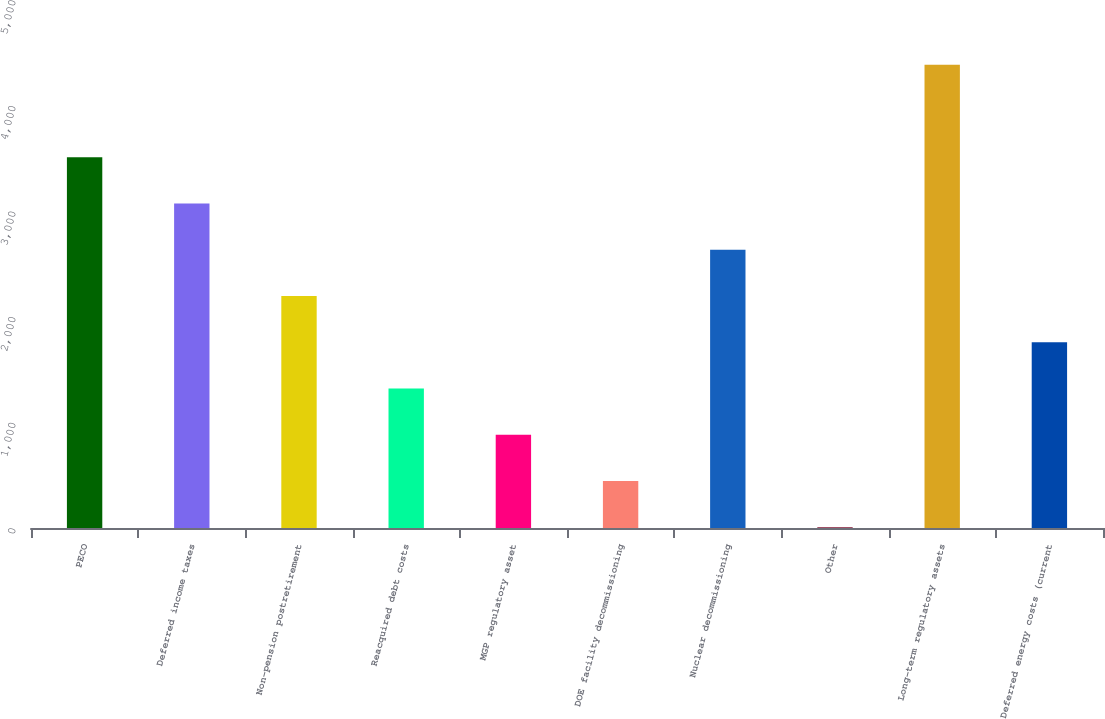Convert chart to OTSL. <chart><loc_0><loc_0><loc_500><loc_500><bar_chart><fcel>PECO<fcel>Deferred income taxes<fcel>Non-pension postretirement<fcel>Reacquired debt costs<fcel>MGP regulatory asset<fcel>DOE facility decommissioning<fcel>Nuclear decommissioning<fcel>Other<fcel>Long-term regulatory assets<fcel>Deferred energy costs (current<nl><fcel>3510.4<fcel>3072.6<fcel>2197<fcel>1321.4<fcel>883.6<fcel>445.8<fcel>2634.8<fcel>8<fcel>4386<fcel>1759.2<nl></chart> 